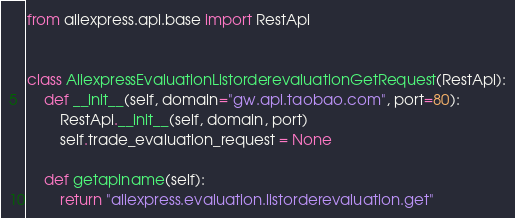Convert code to text. <code><loc_0><loc_0><loc_500><loc_500><_Python_>from aliexpress.api.base import RestApi


class AliexpressEvaluationListorderevaluationGetRequest(RestApi):
    def __init__(self, domain="gw.api.taobao.com", port=80):
        RestApi.__init__(self, domain, port)
        self.trade_evaluation_request = None

    def getapiname(self):
        return "aliexpress.evaluation.listorderevaluation.get"
</code> 